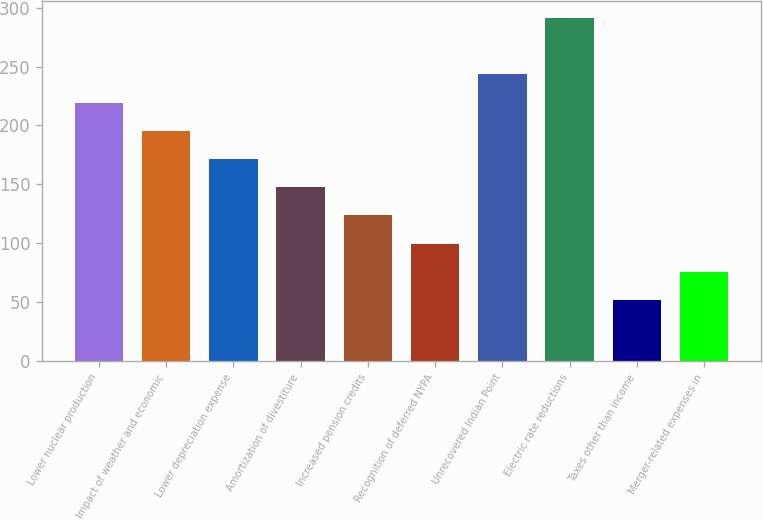Convert chart to OTSL. <chart><loc_0><loc_0><loc_500><loc_500><bar_chart><fcel>Lower nuclear production<fcel>Impact of weather and economic<fcel>Lower depreciation expense<fcel>Amortization of divestiture<fcel>Increased pension credits<fcel>Recognition of deferred NYPA<fcel>Unrecovered Indian Point<fcel>Electric rate reductions<fcel>Taxes other than income<fcel>Merger-related expenses in<nl><fcel>219.44<fcel>195.48<fcel>171.52<fcel>147.56<fcel>123.6<fcel>99.64<fcel>243.4<fcel>291.32<fcel>51.72<fcel>75.68<nl></chart> 